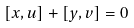Convert formula to latex. <formula><loc_0><loc_0><loc_500><loc_500>[ x , u ] + [ y , v ] = 0</formula> 